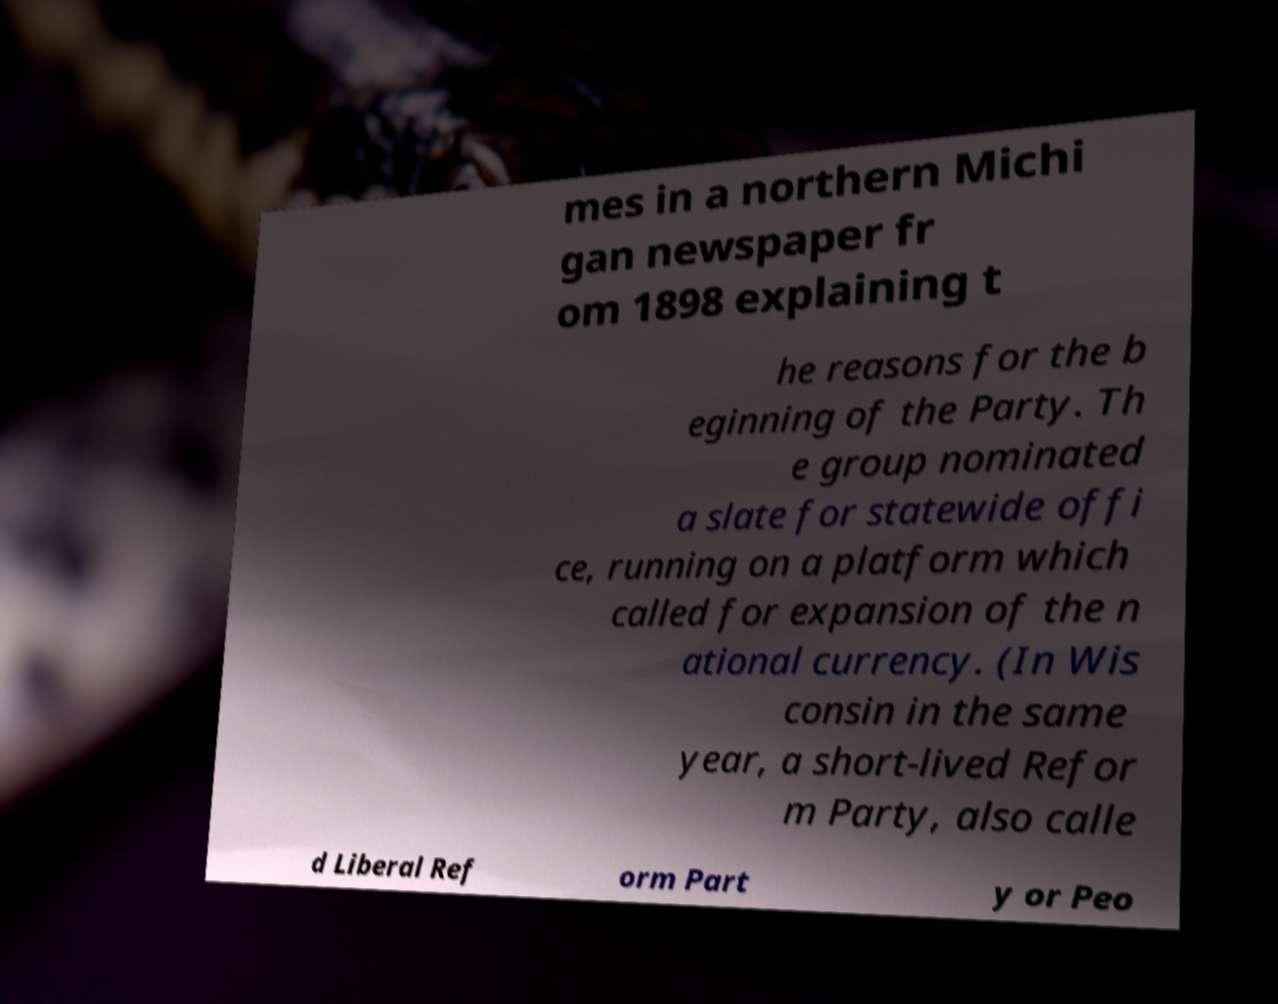Can you accurately transcribe the text from the provided image for me? mes in a northern Michi gan newspaper fr om 1898 explaining t he reasons for the b eginning of the Party. Th e group nominated a slate for statewide offi ce, running on a platform which called for expansion of the n ational currency. (In Wis consin in the same year, a short-lived Refor m Party, also calle d Liberal Ref orm Part y or Peo 